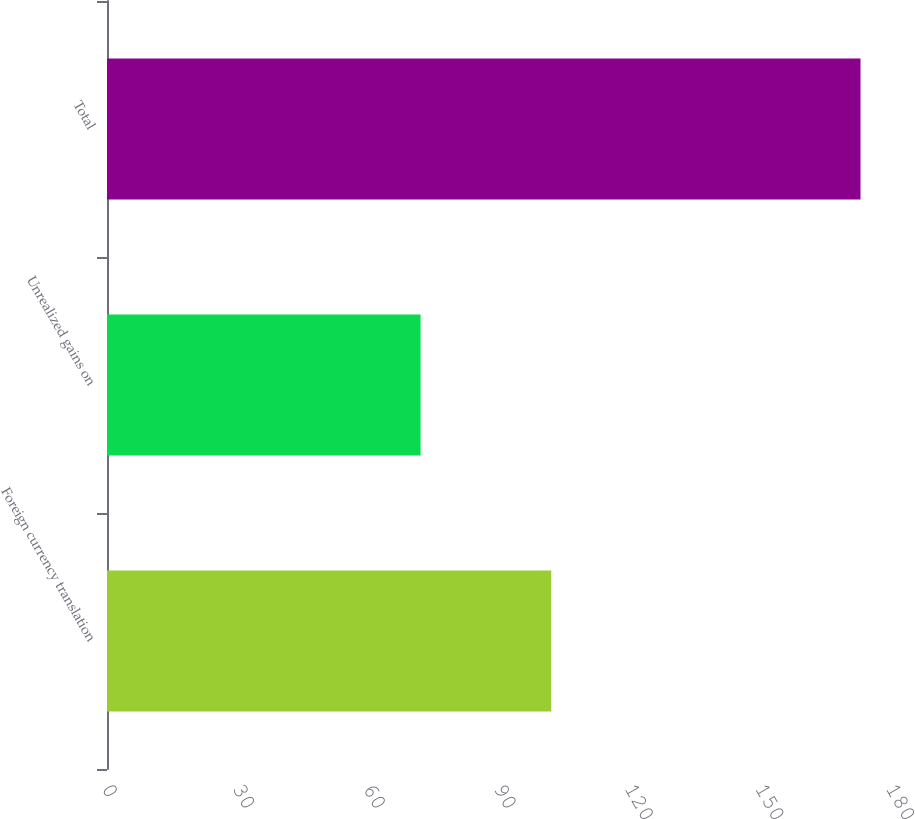Convert chart. <chart><loc_0><loc_0><loc_500><loc_500><bar_chart><fcel>Foreign currency translation<fcel>Unrealized gains on<fcel>Total<nl><fcel>102<fcel>72<fcel>173<nl></chart> 